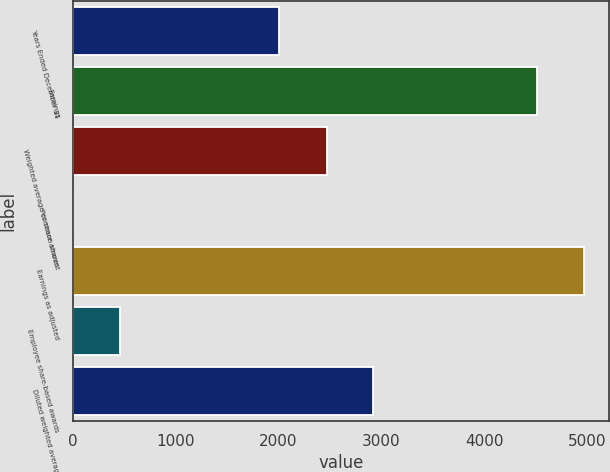<chart> <loc_0><loc_0><loc_500><loc_500><bar_chart><fcel>Years Ended December 31<fcel>Earnings<fcel>Weighted average common shares<fcel>Per share amount<fcel>Earnings as adjusted<fcel>Employee share-based awards<fcel>Diluted weighted average<nl><fcel>2005<fcel>4519<fcel>2471.3<fcel>1.83<fcel>4970.72<fcel>453.55<fcel>2923.02<nl></chart> 